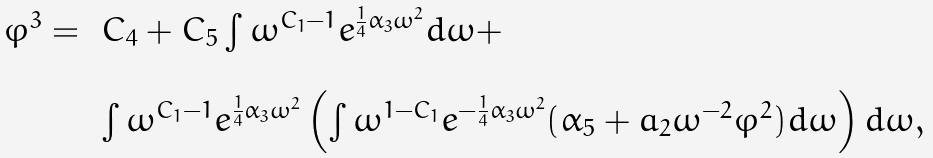<formula> <loc_0><loc_0><loc_500><loc_500>\begin{array} { l l } \varphi ^ { 3 } = \, & C _ { 4 } + C _ { 5 } \int \omega ^ { C _ { 1 } - 1 } e ^ { \frac { 1 } { 4 } \alpha _ { 3 } \omega ^ { 2 } } d \omega + \\ \\ & \int \omega ^ { C _ { 1 } - 1 } e ^ { \frac { 1 } { 4 } \alpha _ { 3 } \omega ^ { 2 } } \left ( \int \omega ^ { 1 - C _ { 1 } } e ^ { - \frac { 1 } { 4 } \alpha _ { 3 } \omega ^ { 2 } } ( \alpha _ { 5 } + a _ { 2 } \omega ^ { - 2 } \varphi ^ { 2 } ) d \omega \right ) d \omega , \end{array}</formula> 